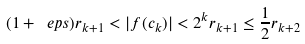Convert formula to latex. <formula><loc_0><loc_0><loc_500><loc_500>( 1 + \ e p s ) r _ { k + 1 } < | f ( c _ { k } ) | < 2 ^ { k } r _ { k + 1 } \leq \frac { 1 } { 2 } r _ { k + 2 }</formula> 